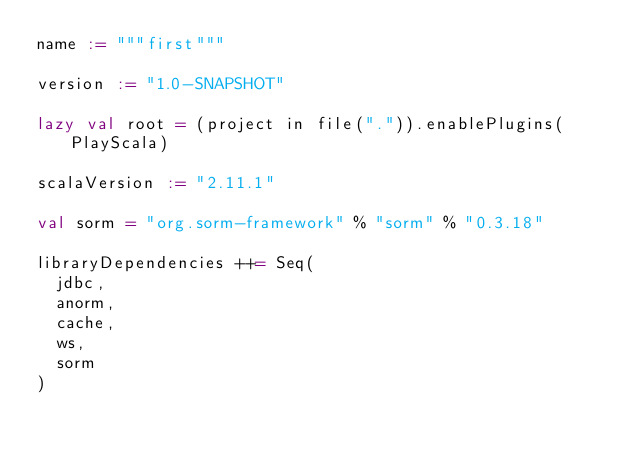Convert code to text. <code><loc_0><loc_0><loc_500><loc_500><_Scala_>name := """first"""

version := "1.0-SNAPSHOT"

lazy val root = (project in file(".")).enablePlugins(PlayScala)

scalaVersion := "2.11.1"

val sorm = "org.sorm-framework" % "sorm" % "0.3.18"

libraryDependencies ++= Seq(
  jdbc,
  anorm,
  cache,
  ws,
  sorm
)


</code> 